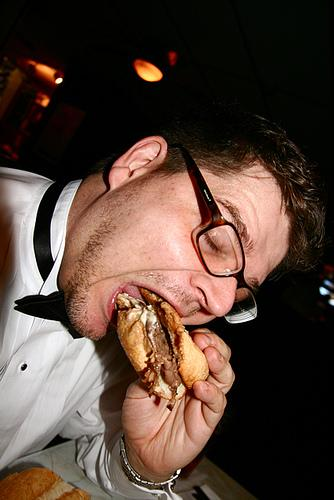What kind of tie is the man wearing? The man is wearing a black bow tie. Briefly describe the man's appearance in the image. The man has brown hair, is wearing a white shirt with a black bow tie and silver watch, and is eating a sandwich. What notable accessories is the man wearing? The man is wearing glasses, a bow tie, and a watch with a silver band. What is the primary action being performed by the man in the image? The man is biting into a messy meat sandwich, enjoying his food. Count the number of objects that the man is wearing on his face. The man is wearing two objects on his face - glasses and a beard. Identify the main object that the man is interacting with in the image. The man is interacting with a sandwich, holding and biting into it. How would you describe the man's demeanor while eating the sandwich? The man is eating the sandwich messily with his eyes closed, seemingly enjoying the experience. List the main ingredients detected in the sandwich. Meat, sauce, and bread make up the sandwich. Determine the color of the man's shirt and the type of its buttons. The man is wearing a white shirt with black buttons. What kind of sandwich is the man eating? The man is eating a messy meat sandwich, possibly roast beef with sauce. Is the man wearing a plain white shirt or a white button-down shirt? The man is wearing a white button-down shirt. Look for the woman in the red dress standing behind the man. There is no mention of a woman, nor a person wearing a red dress in the entire set of captions. This instruction is misleading as it implies there is a second person in the image, which is not supported by the given information. Describe the main action happening in the image. A man is eating a messy meat sandwich. State three objects present in the image. Man wearing glasses, man holding a sandwich, silver watch on wrist. What is the color of the background lights? Orange. Count the number of black buttons in the image. There are two black buttons on the man's shirt. Identify the object described as "silver band on the wrist." The watch. Is the man wearing a gold necklace? No, it's not mentioned in the image. Assess the quality of the image. The image has clear sharp details and good lighting. What type of sandwich is the man eating? A hamburger. Determine the color of the man's hair. The man's hair is reddish brown. What type of meat is in the sandwich? Roast beef. State some details about the sandwich's bread. It is crunchy and toasted. Identify any potential anomalies in the image. No apparent anomalies. Analyze how the man is holding the sandwich. The man's hand is holding the sandwich with fingers on the bread. What object is leaning forward in the image? The man. What is the main feature on the man's wrist? A silver watch with a silver band. Notice the green bottle of hot sauce next to the sandwich. In the provided captions, there is no mention of a bottle or hot sauce. By asking the viewer to notice this specific item, the instruction provides misleading information that doesn't match the actual content of the image. The dog under the table is waiting for a piece of the sandwich to fall. The captions provided do not mention a dog or a table in the image. By adding these non-existent objects, the instruction misleads the viewer into looking for something that isn't there. Describe the man's glasses. The glasses have dark brown frames. 